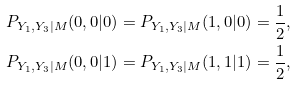<formula> <loc_0><loc_0><loc_500><loc_500>P _ { Y _ { 1 } , Y _ { 3 } | M } ( 0 , 0 | 0 ) = P _ { Y _ { 1 } , Y _ { 3 } | M } ( 1 , 0 | 0 ) = \frac { 1 } { 2 } , \\ P _ { Y _ { 1 } , Y _ { 3 } | M } ( 0 , 0 | 1 ) = P _ { Y _ { 1 } , Y _ { 3 } | M } ( 1 , 1 | 1 ) = \frac { 1 } { 2 } ,</formula> 